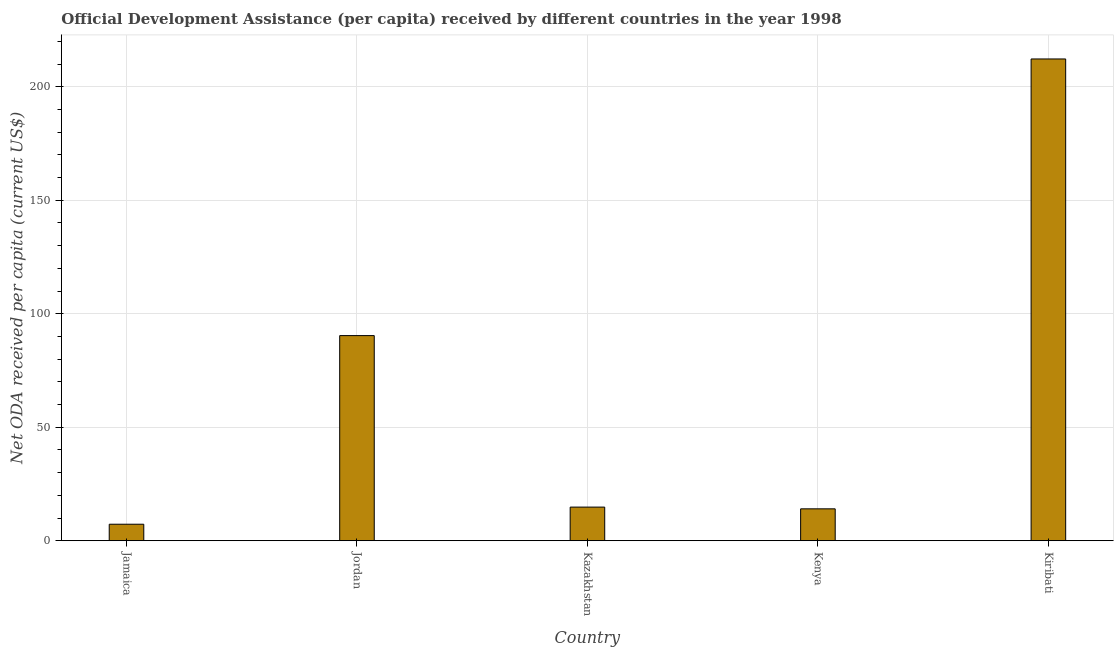Does the graph contain any zero values?
Offer a terse response. No. What is the title of the graph?
Your answer should be compact. Official Development Assistance (per capita) received by different countries in the year 1998. What is the label or title of the X-axis?
Ensure brevity in your answer.  Country. What is the label or title of the Y-axis?
Ensure brevity in your answer.  Net ODA received per capita (current US$). What is the net oda received per capita in Jamaica?
Offer a terse response. 7.26. Across all countries, what is the maximum net oda received per capita?
Offer a terse response. 212.25. Across all countries, what is the minimum net oda received per capita?
Your answer should be very brief. 7.26. In which country was the net oda received per capita maximum?
Your response must be concise. Kiribati. In which country was the net oda received per capita minimum?
Keep it short and to the point. Jamaica. What is the sum of the net oda received per capita?
Your response must be concise. 338.74. What is the difference between the net oda received per capita in Jamaica and Kenya?
Your response must be concise. -6.78. What is the average net oda received per capita per country?
Make the answer very short. 67.75. What is the median net oda received per capita?
Offer a very short reply. 14.81. In how many countries, is the net oda received per capita greater than 210 US$?
Make the answer very short. 1. What is the ratio of the net oda received per capita in Jamaica to that in Kazakhstan?
Ensure brevity in your answer.  0.49. Is the net oda received per capita in Jordan less than that in Kiribati?
Your answer should be compact. Yes. Is the difference between the net oda received per capita in Kazakhstan and Kiribati greater than the difference between any two countries?
Give a very brief answer. No. What is the difference between the highest and the second highest net oda received per capita?
Make the answer very short. 121.88. Is the sum of the net oda received per capita in Jamaica and Kiribati greater than the maximum net oda received per capita across all countries?
Ensure brevity in your answer.  Yes. What is the difference between the highest and the lowest net oda received per capita?
Your answer should be compact. 204.98. Are all the bars in the graph horizontal?
Offer a terse response. No. What is the difference between two consecutive major ticks on the Y-axis?
Your answer should be very brief. 50. What is the Net ODA received per capita (current US$) of Jamaica?
Your response must be concise. 7.26. What is the Net ODA received per capita (current US$) of Jordan?
Your response must be concise. 90.37. What is the Net ODA received per capita (current US$) in Kazakhstan?
Your answer should be compact. 14.81. What is the Net ODA received per capita (current US$) in Kenya?
Provide a succinct answer. 14.04. What is the Net ODA received per capita (current US$) of Kiribati?
Provide a succinct answer. 212.25. What is the difference between the Net ODA received per capita (current US$) in Jamaica and Jordan?
Your answer should be compact. -83.11. What is the difference between the Net ODA received per capita (current US$) in Jamaica and Kazakhstan?
Offer a terse response. -7.55. What is the difference between the Net ODA received per capita (current US$) in Jamaica and Kenya?
Keep it short and to the point. -6.78. What is the difference between the Net ODA received per capita (current US$) in Jamaica and Kiribati?
Ensure brevity in your answer.  -204.98. What is the difference between the Net ODA received per capita (current US$) in Jordan and Kazakhstan?
Your response must be concise. 75.56. What is the difference between the Net ODA received per capita (current US$) in Jordan and Kenya?
Keep it short and to the point. 76.33. What is the difference between the Net ODA received per capita (current US$) in Jordan and Kiribati?
Offer a very short reply. -121.88. What is the difference between the Net ODA received per capita (current US$) in Kazakhstan and Kenya?
Give a very brief answer. 0.77. What is the difference between the Net ODA received per capita (current US$) in Kazakhstan and Kiribati?
Your response must be concise. -197.43. What is the difference between the Net ODA received per capita (current US$) in Kenya and Kiribati?
Keep it short and to the point. -198.2. What is the ratio of the Net ODA received per capita (current US$) in Jamaica to that in Kazakhstan?
Your response must be concise. 0.49. What is the ratio of the Net ODA received per capita (current US$) in Jamaica to that in Kenya?
Ensure brevity in your answer.  0.52. What is the ratio of the Net ODA received per capita (current US$) in Jamaica to that in Kiribati?
Provide a short and direct response. 0.03. What is the ratio of the Net ODA received per capita (current US$) in Jordan to that in Kazakhstan?
Offer a very short reply. 6.1. What is the ratio of the Net ODA received per capita (current US$) in Jordan to that in Kenya?
Offer a very short reply. 6.43. What is the ratio of the Net ODA received per capita (current US$) in Jordan to that in Kiribati?
Give a very brief answer. 0.43. What is the ratio of the Net ODA received per capita (current US$) in Kazakhstan to that in Kenya?
Provide a short and direct response. 1.05. What is the ratio of the Net ODA received per capita (current US$) in Kazakhstan to that in Kiribati?
Ensure brevity in your answer.  0.07. What is the ratio of the Net ODA received per capita (current US$) in Kenya to that in Kiribati?
Your answer should be compact. 0.07. 